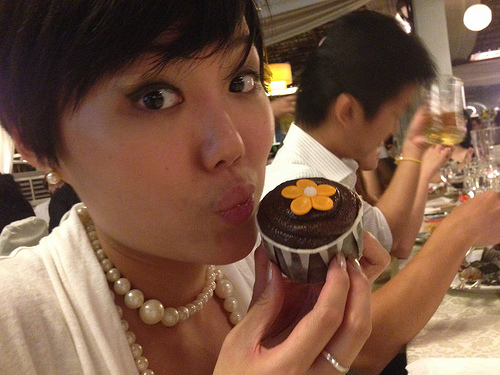Can you describe the expression on the woman's face? The woman appears to have a playful and happy expression as she puckers her lips and holds a dessert with a fondant flower on it. What emotion or event might have elicited such an expression? The woman might be celebrating a special occasion such as a birthday or enjoying a fun moment with friends, which is making her appear playful and joyful. 